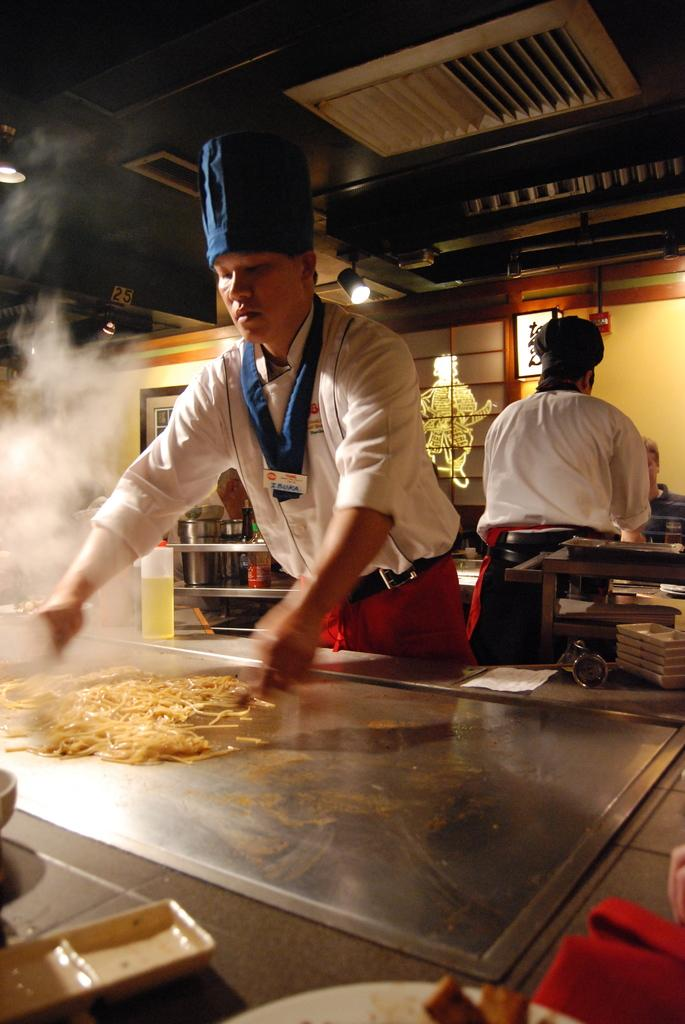How many people are in the image? There are two persons standing in the image. What is one of the persons doing in the image? There is a person cooking something on a cabinet. What can be seen in the image that provides illumination? There are lights visible in the image. Can you describe any other objects present in the image? There are other objects present in the image, but their specific details are not mentioned in the provided facts. What is the fifth person in the image doing? There are only two persons in the image, so there is no fifth person to describe. 